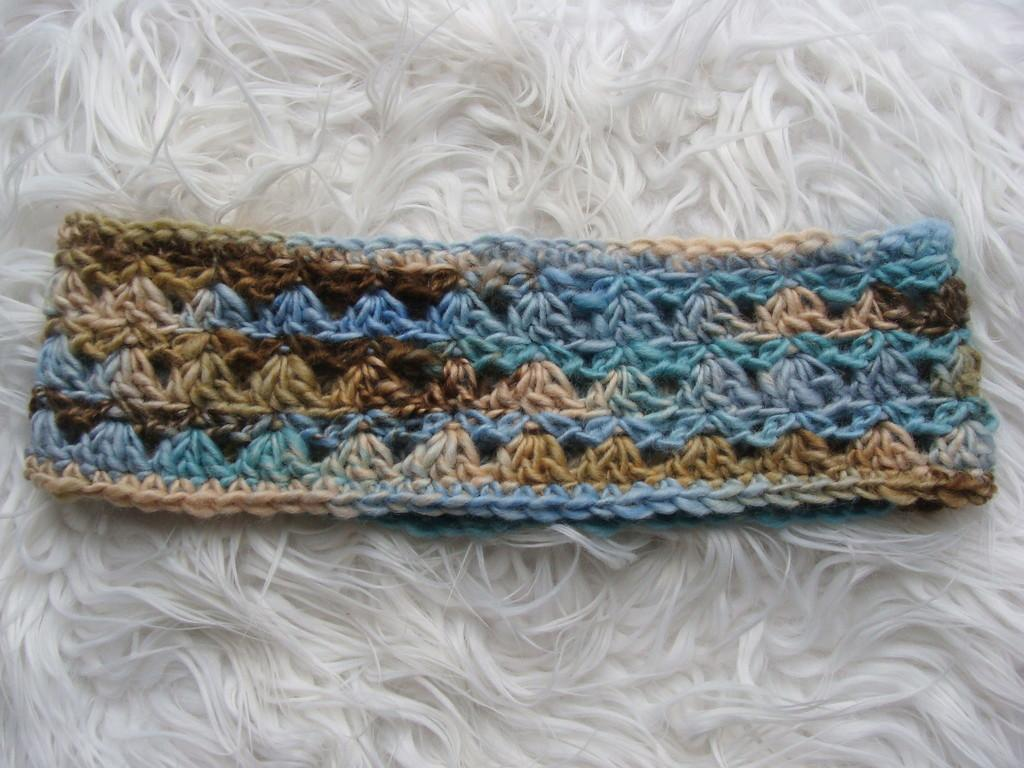What type of material is the main subject of the image made of? The main subject of the image is a knitted cloth. What is the knitted cloth placed on? The knitted cloth is on a white woolen cloth. How many cars are parked on the knitted cloth in the image? There are no cars present in the image; it features a knitted cloth on a white woolen cloth. What type of plant is growing on the knitted cloth in the image? There is no plant present on the knitted cloth in the image. 